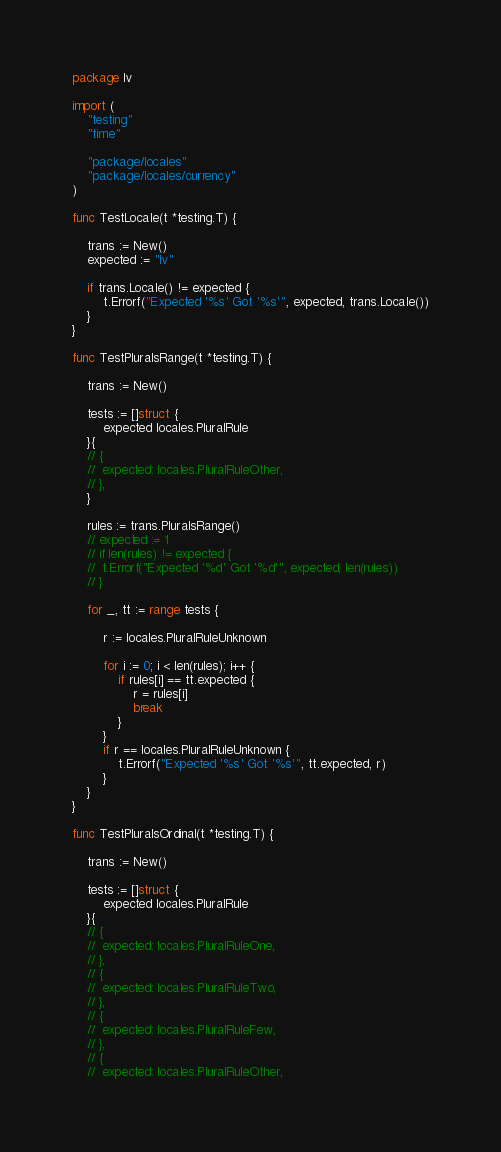Convert code to text. <code><loc_0><loc_0><loc_500><loc_500><_Go_>package lv

import (
	"testing"
	"time"

	"package/locales"
	"package/locales/currency"
)

func TestLocale(t *testing.T) {

	trans := New()
	expected := "lv"

	if trans.Locale() != expected {
		t.Errorf("Expected '%s' Got '%s'", expected, trans.Locale())
	}
}

func TestPluralsRange(t *testing.T) {

	trans := New()

	tests := []struct {
		expected locales.PluralRule
	}{
	// {
	// 	expected: locales.PluralRuleOther,
	// },
	}

	rules := trans.PluralsRange()
	// expected := 1
	// if len(rules) != expected {
	// 	t.Errorf("Expected '%d' Got '%d'", expected, len(rules))
	// }

	for _, tt := range tests {

		r := locales.PluralRuleUnknown

		for i := 0; i < len(rules); i++ {
			if rules[i] == tt.expected {
				r = rules[i]
				break
			}
		}
		if r == locales.PluralRuleUnknown {
			t.Errorf("Expected '%s' Got '%s'", tt.expected, r)
		}
	}
}

func TestPluralsOrdinal(t *testing.T) {

	trans := New()

	tests := []struct {
		expected locales.PluralRule
	}{
	// {
	// 	expected: locales.PluralRuleOne,
	// },
	// {
	// 	expected: locales.PluralRuleTwo,
	// },
	// {
	// 	expected: locales.PluralRuleFew,
	// },
	// {
	// 	expected: locales.PluralRuleOther,</code> 